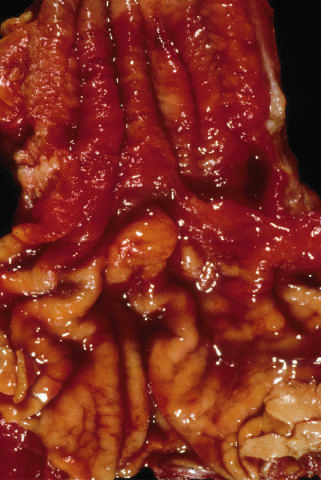what do only a few areas of pale squamous mucosa remain within?
Answer the question using a single word or phrase. The predominantly metaplastic 